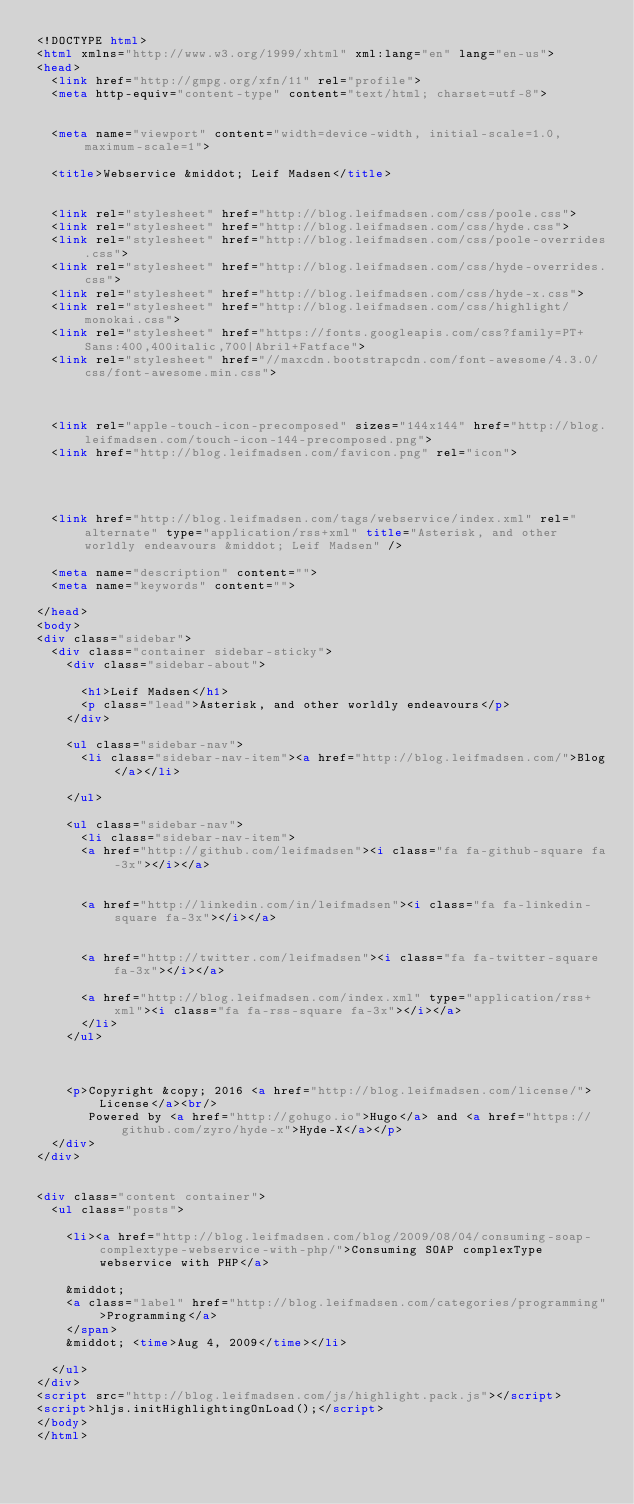<code> <loc_0><loc_0><loc_500><loc_500><_HTML_><!DOCTYPE html>
<html xmlns="http://www.w3.org/1999/xhtml" xml:lang="en" lang="en-us">
<head>
  <link href="http://gmpg.org/xfn/11" rel="profile">
  <meta http-equiv="content-type" content="text/html; charset=utf-8">

  
  <meta name="viewport" content="width=device-width, initial-scale=1.0, maximum-scale=1">

  <title>Webservice &middot; Leif Madsen</title>

  
  <link rel="stylesheet" href="http://blog.leifmadsen.com/css/poole.css">
  <link rel="stylesheet" href="http://blog.leifmadsen.com/css/hyde.css">
  <link rel="stylesheet" href="http://blog.leifmadsen.com/css/poole-overrides.css">
  <link rel="stylesheet" href="http://blog.leifmadsen.com/css/hyde-overrides.css">
  <link rel="stylesheet" href="http://blog.leifmadsen.com/css/hyde-x.css">
  <link rel="stylesheet" href="http://blog.leifmadsen.com/css/highlight/monokai.css">
  <link rel="stylesheet" href="https://fonts.googleapis.com/css?family=PT+Sans:400,400italic,700|Abril+Fatface">
  <link rel="stylesheet" href="//maxcdn.bootstrapcdn.com/font-awesome/4.3.0/css/font-awesome.min.css">
  

  
  <link rel="apple-touch-icon-precomposed" sizes="144x144" href="http://blog.leifmadsen.com/touch-icon-144-precomposed.png">
  <link href="http://blog.leifmadsen.com/favicon.png" rel="icon">

  
  
  
  <link href="http://blog.leifmadsen.com/tags/webservice/index.xml" rel="alternate" type="application/rss+xml" title="Asterisk, and other worldly endeavours &middot; Leif Madsen" />

  <meta name="description" content="">
  <meta name="keywords" content="">
  
</head>
<body>
<div class="sidebar">
  <div class="container sidebar-sticky">
    <div class="sidebar-about">
      
      <h1>Leif Madsen</h1>
      <p class="lead">Asterisk, and other worldly endeavours</p>
    </div>

    <ul class="sidebar-nav">
      <li class="sidebar-nav-item"><a href="http://blog.leifmadsen.com/">Blog</a></li>
      
    </ul>

    <ul class="sidebar-nav">
      <li class="sidebar-nav-item">
      <a href="http://github.com/leifmadsen"><i class="fa fa-github-square fa-3x"></i></a>
      
      
      <a href="http://linkedin.com/in/leifmadsen"><i class="fa fa-linkedin-square fa-3x"></i></a>
      
      
      <a href="http://twitter.com/leifmadsen"><i class="fa fa-twitter-square fa-3x"></i></a>
      
      <a href="http://blog.leifmadsen.com/index.xml" type="application/rss+xml"><i class="fa fa-rss-square fa-3x"></i></a>
      </li>
    </ul>

    

    <p>Copyright &copy; 2016 <a href="http://blog.leifmadsen.com/license/">License</a><br/>
       Powered by <a href="http://gohugo.io">Hugo</a> and <a href="https://github.com/zyro/hyde-x">Hyde-X</a></p>
  </div>
</div>


<div class="content container">
  <ul class="posts">
  
    <li><a href="http://blog.leifmadsen.com/blog/2009/08/04/consuming-soap-complextype-webservice-with-php/">Consuming SOAP complexType webservice with PHP</a>
    
    &middot;
    <a class="label" href="http://blog.leifmadsen.com/categories/programming">Programming</a>
    </span>
    &middot; <time>Aug 4, 2009</time></li>
  
  </ul>
</div>
<script src="http://blog.leifmadsen.com/js/highlight.pack.js"></script>
<script>hljs.initHighlightingOnLoad();</script>
</body>
</html>

</code> 